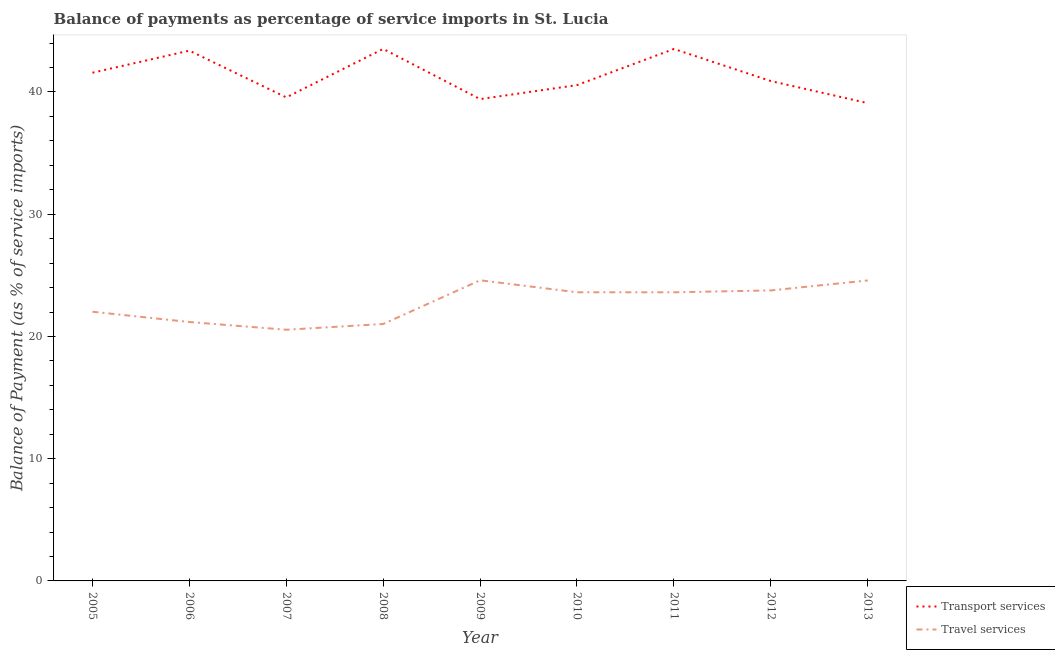Does the line corresponding to balance of payments of travel services intersect with the line corresponding to balance of payments of transport services?
Ensure brevity in your answer.  No. What is the balance of payments of travel services in 2009?
Make the answer very short. 24.6. Across all years, what is the maximum balance of payments of travel services?
Your response must be concise. 24.6. Across all years, what is the minimum balance of payments of travel services?
Your answer should be very brief. 20.55. In which year was the balance of payments of transport services minimum?
Make the answer very short. 2013. What is the total balance of payments of transport services in the graph?
Your answer should be compact. 371.53. What is the difference between the balance of payments of travel services in 2006 and that in 2011?
Your answer should be very brief. -2.43. What is the difference between the balance of payments of transport services in 2007 and the balance of payments of travel services in 2011?
Keep it short and to the point. 15.95. What is the average balance of payments of transport services per year?
Your answer should be very brief. 41.28. In the year 2009, what is the difference between the balance of payments of travel services and balance of payments of transport services?
Your response must be concise. -14.82. What is the ratio of the balance of payments of travel services in 2006 to that in 2009?
Offer a very short reply. 0.86. Is the difference between the balance of payments of travel services in 2007 and 2011 greater than the difference between the balance of payments of transport services in 2007 and 2011?
Keep it short and to the point. Yes. What is the difference between the highest and the second highest balance of payments of travel services?
Your answer should be very brief. 0.01. What is the difference between the highest and the lowest balance of payments of transport services?
Your response must be concise. 4.43. In how many years, is the balance of payments of travel services greater than the average balance of payments of travel services taken over all years?
Your answer should be very brief. 5. Is the balance of payments of travel services strictly less than the balance of payments of transport services over the years?
Make the answer very short. Yes. How many years are there in the graph?
Your answer should be compact. 9. What is the difference between two consecutive major ticks on the Y-axis?
Offer a terse response. 10. Does the graph contain grids?
Provide a succinct answer. No. Where does the legend appear in the graph?
Your answer should be compact. Bottom right. What is the title of the graph?
Your response must be concise. Balance of payments as percentage of service imports in St. Lucia. Does "Non-pregnant women" appear as one of the legend labels in the graph?
Make the answer very short. No. What is the label or title of the Y-axis?
Keep it short and to the point. Balance of Payment (as % of service imports). What is the Balance of Payment (as % of service imports) in Transport services in 2005?
Give a very brief answer. 41.58. What is the Balance of Payment (as % of service imports) in Travel services in 2005?
Provide a short and direct response. 22.02. What is the Balance of Payment (as % of service imports) of Transport services in 2006?
Ensure brevity in your answer.  43.38. What is the Balance of Payment (as % of service imports) in Travel services in 2006?
Ensure brevity in your answer.  21.18. What is the Balance of Payment (as % of service imports) of Transport services in 2007?
Ensure brevity in your answer.  39.56. What is the Balance of Payment (as % of service imports) in Travel services in 2007?
Your response must be concise. 20.55. What is the Balance of Payment (as % of service imports) in Transport services in 2008?
Make the answer very short. 43.52. What is the Balance of Payment (as % of service imports) in Travel services in 2008?
Keep it short and to the point. 21.02. What is the Balance of Payment (as % of service imports) of Transport services in 2009?
Give a very brief answer. 39.42. What is the Balance of Payment (as % of service imports) in Travel services in 2009?
Give a very brief answer. 24.6. What is the Balance of Payment (as % of service imports) of Transport services in 2010?
Keep it short and to the point. 40.56. What is the Balance of Payment (as % of service imports) of Travel services in 2010?
Ensure brevity in your answer.  23.61. What is the Balance of Payment (as % of service imports) of Transport services in 2011?
Ensure brevity in your answer.  43.52. What is the Balance of Payment (as % of service imports) in Travel services in 2011?
Make the answer very short. 23.61. What is the Balance of Payment (as % of service imports) in Transport services in 2012?
Make the answer very short. 40.9. What is the Balance of Payment (as % of service imports) in Travel services in 2012?
Make the answer very short. 23.77. What is the Balance of Payment (as % of service imports) in Transport services in 2013?
Your response must be concise. 39.09. What is the Balance of Payment (as % of service imports) of Travel services in 2013?
Keep it short and to the point. 24.58. Across all years, what is the maximum Balance of Payment (as % of service imports) of Transport services?
Your answer should be compact. 43.52. Across all years, what is the maximum Balance of Payment (as % of service imports) of Travel services?
Give a very brief answer. 24.6. Across all years, what is the minimum Balance of Payment (as % of service imports) in Transport services?
Your answer should be very brief. 39.09. Across all years, what is the minimum Balance of Payment (as % of service imports) in Travel services?
Ensure brevity in your answer.  20.55. What is the total Balance of Payment (as % of service imports) of Transport services in the graph?
Make the answer very short. 371.53. What is the total Balance of Payment (as % of service imports) of Travel services in the graph?
Provide a succinct answer. 204.95. What is the difference between the Balance of Payment (as % of service imports) of Transport services in 2005 and that in 2006?
Offer a very short reply. -1.81. What is the difference between the Balance of Payment (as % of service imports) in Travel services in 2005 and that in 2006?
Provide a succinct answer. 0.84. What is the difference between the Balance of Payment (as % of service imports) of Transport services in 2005 and that in 2007?
Your answer should be very brief. 2.02. What is the difference between the Balance of Payment (as % of service imports) in Travel services in 2005 and that in 2007?
Your answer should be compact. 1.47. What is the difference between the Balance of Payment (as % of service imports) in Transport services in 2005 and that in 2008?
Your response must be concise. -1.95. What is the difference between the Balance of Payment (as % of service imports) of Travel services in 2005 and that in 2008?
Provide a succinct answer. 1. What is the difference between the Balance of Payment (as % of service imports) of Transport services in 2005 and that in 2009?
Keep it short and to the point. 2.16. What is the difference between the Balance of Payment (as % of service imports) of Travel services in 2005 and that in 2009?
Make the answer very short. -2.57. What is the difference between the Balance of Payment (as % of service imports) in Transport services in 2005 and that in 2010?
Give a very brief answer. 1.01. What is the difference between the Balance of Payment (as % of service imports) of Travel services in 2005 and that in 2010?
Offer a terse response. -1.59. What is the difference between the Balance of Payment (as % of service imports) in Transport services in 2005 and that in 2011?
Ensure brevity in your answer.  -1.94. What is the difference between the Balance of Payment (as % of service imports) in Travel services in 2005 and that in 2011?
Your response must be concise. -1.59. What is the difference between the Balance of Payment (as % of service imports) in Transport services in 2005 and that in 2012?
Ensure brevity in your answer.  0.68. What is the difference between the Balance of Payment (as % of service imports) of Travel services in 2005 and that in 2012?
Your response must be concise. -1.74. What is the difference between the Balance of Payment (as % of service imports) of Transport services in 2005 and that in 2013?
Offer a terse response. 2.49. What is the difference between the Balance of Payment (as % of service imports) of Travel services in 2005 and that in 2013?
Provide a short and direct response. -2.56. What is the difference between the Balance of Payment (as % of service imports) of Transport services in 2006 and that in 2007?
Offer a terse response. 3.83. What is the difference between the Balance of Payment (as % of service imports) of Travel services in 2006 and that in 2007?
Provide a short and direct response. 0.63. What is the difference between the Balance of Payment (as % of service imports) in Transport services in 2006 and that in 2008?
Give a very brief answer. -0.14. What is the difference between the Balance of Payment (as % of service imports) in Travel services in 2006 and that in 2008?
Provide a succinct answer. 0.16. What is the difference between the Balance of Payment (as % of service imports) in Transport services in 2006 and that in 2009?
Keep it short and to the point. 3.97. What is the difference between the Balance of Payment (as % of service imports) of Travel services in 2006 and that in 2009?
Provide a short and direct response. -3.41. What is the difference between the Balance of Payment (as % of service imports) in Transport services in 2006 and that in 2010?
Your answer should be compact. 2.82. What is the difference between the Balance of Payment (as % of service imports) of Travel services in 2006 and that in 2010?
Offer a very short reply. -2.43. What is the difference between the Balance of Payment (as % of service imports) in Transport services in 2006 and that in 2011?
Offer a terse response. -0.14. What is the difference between the Balance of Payment (as % of service imports) of Travel services in 2006 and that in 2011?
Your answer should be compact. -2.43. What is the difference between the Balance of Payment (as % of service imports) of Transport services in 2006 and that in 2012?
Provide a short and direct response. 2.49. What is the difference between the Balance of Payment (as % of service imports) in Travel services in 2006 and that in 2012?
Keep it short and to the point. -2.58. What is the difference between the Balance of Payment (as % of service imports) of Transport services in 2006 and that in 2013?
Your answer should be very brief. 4.29. What is the difference between the Balance of Payment (as % of service imports) of Travel services in 2006 and that in 2013?
Offer a very short reply. -3.4. What is the difference between the Balance of Payment (as % of service imports) of Transport services in 2007 and that in 2008?
Ensure brevity in your answer.  -3.97. What is the difference between the Balance of Payment (as % of service imports) in Travel services in 2007 and that in 2008?
Give a very brief answer. -0.47. What is the difference between the Balance of Payment (as % of service imports) in Transport services in 2007 and that in 2009?
Keep it short and to the point. 0.14. What is the difference between the Balance of Payment (as % of service imports) in Travel services in 2007 and that in 2009?
Provide a succinct answer. -4.05. What is the difference between the Balance of Payment (as % of service imports) of Transport services in 2007 and that in 2010?
Keep it short and to the point. -1.01. What is the difference between the Balance of Payment (as % of service imports) of Travel services in 2007 and that in 2010?
Keep it short and to the point. -3.06. What is the difference between the Balance of Payment (as % of service imports) of Transport services in 2007 and that in 2011?
Offer a very short reply. -3.96. What is the difference between the Balance of Payment (as % of service imports) of Travel services in 2007 and that in 2011?
Your answer should be very brief. -3.06. What is the difference between the Balance of Payment (as % of service imports) of Transport services in 2007 and that in 2012?
Ensure brevity in your answer.  -1.34. What is the difference between the Balance of Payment (as % of service imports) of Travel services in 2007 and that in 2012?
Ensure brevity in your answer.  -3.22. What is the difference between the Balance of Payment (as % of service imports) of Transport services in 2007 and that in 2013?
Ensure brevity in your answer.  0.47. What is the difference between the Balance of Payment (as % of service imports) in Travel services in 2007 and that in 2013?
Provide a succinct answer. -4.03. What is the difference between the Balance of Payment (as % of service imports) of Transport services in 2008 and that in 2009?
Offer a very short reply. 4.11. What is the difference between the Balance of Payment (as % of service imports) in Travel services in 2008 and that in 2009?
Offer a terse response. -3.58. What is the difference between the Balance of Payment (as % of service imports) of Transport services in 2008 and that in 2010?
Keep it short and to the point. 2.96. What is the difference between the Balance of Payment (as % of service imports) of Travel services in 2008 and that in 2010?
Your response must be concise. -2.59. What is the difference between the Balance of Payment (as % of service imports) of Transport services in 2008 and that in 2011?
Your response must be concise. 0. What is the difference between the Balance of Payment (as % of service imports) of Travel services in 2008 and that in 2011?
Make the answer very short. -2.59. What is the difference between the Balance of Payment (as % of service imports) of Transport services in 2008 and that in 2012?
Your answer should be compact. 2.63. What is the difference between the Balance of Payment (as % of service imports) of Travel services in 2008 and that in 2012?
Your answer should be compact. -2.75. What is the difference between the Balance of Payment (as % of service imports) in Transport services in 2008 and that in 2013?
Make the answer very short. 4.43. What is the difference between the Balance of Payment (as % of service imports) in Travel services in 2008 and that in 2013?
Your response must be concise. -3.56. What is the difference between the Balance of Payment (as % of service imports) of Transport services in 2009 and that in 2010?
Your response must be concise. -1.15. What is the difference between the Balance of Payment (as % of service imports) of Travel services in 2009 and that in 2010?
Your answer should be very brief. 0.98. What is the difference between the Balance of Payment (as % of service imports) of Transport services in 2009 and that in 2011?
Your answer should be compact. -4.1. What is the difference between the Balance of Payment (as % of service imports) in Travel services in 2009 and that in 2011?
Your answer should be very brief. 0.98. What is the difference between the Balance of Payment (as % of service imports) in Transport services in 2009 and that in 2012?
Your response must be concise. -1.48. What is the difference between the Balance of Payment (as % of service imports) in Travel services in 2009 and that in 2012?
Your answer should be compact. 0.83. What is the difference between the Balance of Payment (as % of service imports) in Transport services in 2009 and that in 2013?
Offer a terse response. 0.33. What is the difference between the Balance of Payment (as % of service imports) of Travel services in 2009 and that in 2013?
Make the answer very short. 0.01. What is the difference between the Balance of Payment (as % of service imports) in Transport services in 2010 and that in 2011?
Your answer should be very brief. -2.96. What is the difference between the Balance of Payment (as % of service imports) of Travel services in 2010 and that in 2011?
Give a very brief answer. 0. What is the difference between the Balance of Payment (as % of service imports) of Transport services in 2010 and that in 2012?
Offer a terse response. -0.33. What is the difference between the Balance of Payment (as % of service imports) of Travel services in 2010 and that in 2012?
Give a very brief answer. -0.15. What is the difference between the Balance of Payment (as % of service imports) of Transport services in 2010 and that in 2013?
Your answer should be very brief. 1.47. What is the difference between the Balance of Payment (as % of service imports) of Travel services in 2010 and that in 2013?
Your answer should be compact. -0.97. What is the difference between the Balance of Payment (as % of service imports) of Transport services in 2011 and that in 2012?
Provide a succinct answer. 2.62. What is the difference between the Balance of Payment (as % of service imports) of Travel services in 2011 and that in 2012?
Provide a succinct answer. -0.15. What is the difference between the Balance of Payment (as % of service imports) of Transport services in 2011 and that in 2013?
Provide a short and direct response. 4.43. What is the difference between the Balance of Payment (as % of service imports) in Travel services in 2011 and that in 2013?
Give a very brief answer. -0.97. What is the difference between the Balance of Payment (as % of service imports) of Transport services in 2012 and that in 2013?
Make the answer very short. 1.81. What is the difference between the Balance of Payment (as % of service imports) in Travel services in 2012 and that in 2013?
Your answer should be very brief. -0.82. What is the difference between the Balance of Payment (as % of service imports) of Transport services in 2005 and the Balance of Payment (as % of service imports) of Travel services in 2006?
Make the answer very short. 20.4. What is the difference between the Balance of Payment (as % of service imports) in Transport services in 2005 and the Balance of Payment (as % of service imports) in Travel services in 2007?
Offer a terse response. 21.03. What is the difference between the Balance of Payment (as % of service imports) in Transport services in 2005 and the Balance of Payment (as % of service imports) in Travel services in 2008?
Your answer should be compact. 20.56. What is the difference between the Balance of Payment (as % of service imports) of Transport services in 2005 and the Balance of Payment (as % of service imports) of Travel services in 2009?
Your answer should be very brief. 16.98. What is the difference between the Balance of Payment (as % of service imports) of Transport services in 2005 and the Balance of Payment (as % of service imports) of Travel services in 2010?
Ensure brevity in your answer.  17.96. What is the difference between the Balance of Payment (as % of service imports) of Transport services in 2005 and the Balance of Payment (as % of service imports) of Travel services in 2011?
Provide a succinct answer. 17.96. What is the difference between the Balance of Payment (as % of service imports) of Transport services in 2005 and the Balance of Payment (as % of service imports) of Travel services in 2012?
Your answer should be compact. 17.81. What is the difference between the Balance of Payment (as % of service imports) of Transport services in 2005 and the Balance of Payment (as % of service imports) of Travel services in 2013?
Provide a succinct answer. 17. What is the difference between the Balance of Payment (as % of service imports) of Transport services in 2006 and the Balance of Payment (as % of service imports) of Travel services in 2007?
Provide a succinct answer. 22.83. What is the difference between the Balance of Payment (as % of service imports) in Transport services in 2006 and the Balance of Payment (as % of service imports) in Travel services in 2008?
Make the answer very short. 22.36. What is the difference between the Balance of Payment (as % of service imports) of Transport services in 2006 and the Balance of Payment (as % of service imports) of Travel services in 2009?
Ensure brevity in your answer.  18.79. What is the difference between the Balance of Payment (as % of service imports) in Transport services in 2006 and the Balance of Payment (as % of service imports) in Travel services in 2010?
Provide a succinct answer. 19.77. What is the difference between the Balance of Payment (as % of service imports) of Transport services in 2006 and the Balance of Payment (as % of service imports) of Travel services in 2011?
Your response must be concise. 19.77. What is the difference between the Balance of Payment (as % of service imports) in Transport services in 2006 and the Balance of Payment (as % of service imports) in Travel services in 2012?
Offer a terse response. 19.62. What is the difference between the Balance of Payment (as % of service imports) of Transport services in 2006 and the Balance of Payment (as % of service imports) of Travel services in 2013?
Provide a succinct answer. 18.8. What is the difference between the Balance of Payment (as % of service imports) in Transport services in 2007 and the Balance of Payment (as % of service imports) in Travel services in 2008?
Offer a terse response. 18.54. What is the difference between the Balance of Payment (as % of service imports) of Transport services in 2007 and the Balance of Payment (as % of service imports) of Travel services in 2009?
Your answer should be very brief. 14.96. What is the difference between the Balance of Payment (as % of service imports) in Transport services in 2007 and the Balance of Payment (as % of service imports) in Travel services in 2010?
Ensure brevity in your answer.  15.94. What is the difference between the Balance of Payment (as % of service imports) of Transport services in 2007 and the Balance of Payment (as % of service imports) of Travel services in 2011?
Offer a very short reply. 15.95. What is the difference between the Balance of Payment (as % of service imports) of Transport services in 2007 and the Balance of Payment (as % of service imports) of Travel services in 2012?
Your answer should be very brief. 15.79. What is the difference between the Balance of Payment (as % of service imports) in Transport services in 2007 and the Balance of Payment (as % of service imports) in Travel services in 2013?
Offer a very short reply. 14.98. What is the difference between the Balance of Payment (as % of service imports) in Transport services in 2008 and the Balance of Payment (as % of service imports) in Travel services in 2009?
Ensure brevity in your answer.  18.93. What is the difference between the Balance of Payment (as % of service imports) of Transport services in 2008 and the Balance of Payment (as % of service imports) of Travel services in 2010?
Make the answer very short. 19.91. What is the difference between the Balance of Payment (as % of service imports) in Transport services in 2008 and the Balance of Payment (as % of service imports) in Travel services in 2011?
Offer a terse response. 19.91. What is the difference between the Balance of Payment (as % of service imports) in Transport services in 2008 and the Balance of Payment (as % of service imports) in Travel services in 2012?
Keep it short and to the point. 19.76. What is the difference between the Balance of Payment (as % of service imports) in Transport services in 2008 and the Balance of Payment (as % of service imports) in Travel services in 2013?
Provide a succinct answer. 18.94. What is the difference between the Balance of Payment (as % of service imports) of Transport services in 2009 and the Balance of Payment (as % of service imports) of Travel services in 2010?
Your answer should be very brief. 15.8. What is the difference between the Balance of Payment (as % of service imports) in Transport services in 2009 and the Balance of Payment (as % of service imports) in Travel services in 2011?
Your response must be concise. 15.81. What is the difference between the Balance of Payment (as % of service imports) of Transport services in 2009 and the Balance of Payment (as % of service imports) of Travel services in 2012?
Offer a terse response. 15.65. What is the difference between the Balance of Payment (as % of service imports) in Transport services in 2009 and the Balance of Payment (as % of service imports) in Travel services in 2013?
Your answer should be very brief. 14.84. What is the difference between the Balance of Payment (as % of service imports) in Transport services in 2010 and the Balance of Payment (as % of service imports) in Travel services in 2011?
Provide a short and direct response. 16.95. What is the difference between the Balance of Payment (as % of service imports) of Transport services in 2010 and the Balance of Payment (as % of service imports) of Travel services in 2012?
Make the answer very short. 16.8. What is the difference between the Balance of Payment (as % of service imports) in Transport services in 2010 and the Balance of Payment (as % of service imports) in Travel services in 2013?
Offer a terse response. 15.98. What is the difference between the Balance of Payment (as % of service imports) in Transport services in 2011 and the Balance of Payment (as % of service imports) in Travel services in 2012?
Keep it short and to the point. 19.75. What is the difference between the Balance of Payment (as % of service imports) of Transport services in 2011 and the Balance of Payment (as % of service imports) of Travel services in 2013?
Provide a short and direct response. 18.94. What is the difference between the Balance of Payment (as % of service imports) in Transport services in 2012 and the Balance of Payment (as % of service imports) in Travel services in 2013?
Keep it short and to the point. 16.31. What is the average Balance of Payment (as % of service imports) in Transport services per year?
Ensure brevity in your answer.  41.28. What is the average Balance of Payment (as % of service imports) of Travel services per year?
Your response must be concise. 22.77. In the year 2005, what is the difference between the Balance of Payment (as % of service imports) in Transport services and Balance of Payment (as % of service imports) in Travel services?
Offer a terse response. 19.55. In the year 2006, what is the difference between the Balance of Payment (as % of service imports) of Transport services and Balance of Payment (as % of service imports) of Travel services?
Make the answer very short. 22.2. In the year 2007, what is the difference between the Balance of Payment (as % of service imports) in Transport services and Balance of Payment (as % of service imports) in Travel services?
Your answer should be compact. 19.01. In the year 2008, what is the difference between the Balance of Payment (as % of service imports) in Transport services and Balance of Payment (as % of service imports) in Travel services?
Offer a very short reply. 22.5. In the year 2009, what is the difference between the Balance of Payment (as % of service imports) in Transport services and Balance of Payment (as % of service imports) in Travel services?
Give a very brief answer. 14.82. In the year 2010, what is the difference between the Balance of Payment (as % of service imports) in Transport services and Balance of Payment (as % of service imports) in Travel services?
Your answer should be compact. 16.95. In the year 2011, what is the difference between the Balance of Payment (as % of service imports) of Transport services and Balance of Payment (as % of service imports) of Travel services?
Provide a succinct answer. 19.91. In the year 2012, what is the difference between the Balance of Payment (as % of service imports) of Transport services and Balance of Payment (as % of service imports) of Travel services?
Keep it short and to the point. 17.13. In the year 2013, what is the difference between the Balance of Payment (as % of service imports) of Transport services and Balance of Payment (as % of service imports) of Travel services?
Keep it short and to the point. 14.51. What is the ratio of the Balance of Payment (as % of service imports) of Transport services in 2005 to that in 2006?
Your answer should be very brief. 0.96. What is the ratio of the Balance of Payment (as % of service imports) in Travel services in 2005 to that in 2006?
Give a very brief answer. 1.04. What is the ratio of the Balance of Payment (as % of service imports) in Transport services in 2005 to that in 2007?
Offer a very short reply. 1.05. What is the ratio of the Balance of Payment (as % of service imports) in Travel services in 2005 to that in 2007?
Keep it short and to the point. 1.07. What is the ratio of the Balance of Payment (as % of service imports) of Transport services in 2005 to that in 2008?
Your answer should be very brief. 0.96. What is the ratio of the Balance of Payment (as % of service imports) in Travel services in 2005 to that in 2008?
Provide a succinct answer. 1.05. What is the ratio of the Balance of Payment (as % of service imports) in Transport services in 2005 to that in 2009?
Your answer should be very brief. 1.05. What is the ratio of the Balance of Payment (as % of service imports) in Travel services in 2005 to that in 2009?
Provide a succinct answer. 0.9. What is the ratio of the Balance of Payment (as % of service imports) of Transport services in 2005 to that in 2010?
Make the answer very short. 1.02. What is the ratio of the Balance of Payment (as % of service imports) of Travel services in 2005 to that in 2010?
Provide a succinct answer. 0.93. What is the ratio of the Balance of Payment (as % of service imports) of Transport services in 2005 to that in 2011?
Offer a very short reply. 0.96. What is the ratio of the Balance of Payment (as % of service imports) of Travel services in 2005 to that in 2011?
Provide a succinct answer. 0.93. What is the ratio of the Balance of Payment (as % of service imports) in Transport services in 2005 to that in 2012?
Your answer should be compact. 1.02. What is the ratio of the Balance of Payment (as % of service imports) of Travel services in 2005 to that in 2012?
Give a very brief answer. 0.93. What is the ratio of the Balance of Payment (as % of service imports) of Transport services in 2005 to that in 2013?
Offer a very short reply. 1.06. What is the ratio of the Balance of Payment (as % of service imports) of Travel services in 2005 to that in 2013?
Keep it short and to the point. 0.9. What is the ratio of the Balance of Payment (as % of service imports) of Transport services in 2006 to that in 2007?
Offer a terse response. 1.1. What is the ratio of the Balance of Payment (as % of service imports) of Travel services in 2006 to that in 2007?
Your answer should be compact. 1.03. What is the ratio of the Balance of Payment (as % of service imports) in Transport services in 2006 to that in 2008?
Offer a very short reply. 1. What is the ratio of the Balance of Payment (as % of service imports) of Travel services in 2006 to that in 2008?
Offer a very short reply. 1.01. What is the ratio of the Balance of Payment (as % of service imports) of Transport services in 2006 to that in 2009?
Provide a succinct answer. 1.1. What is the ratio of the Balance of Payment (as % of service imports) in Travel services in 2006 to that in 2009?
Your response must be concise. 0.86. What is the ratio of the Balance of Payment (as % of service imports) in Transport services in 2006 to that in 2010?
Provide a short and direct response. 1.07. What is the ratio of the Balance of Payment (as % of service imports) of Travel services in 2006 to that in 2010?
Make the answer very short. 0.9. What is the ratio of the Balance of Payment (as % of service imports) in Transport services in 2006 to that in 2011?
Keep it short and to the point. 1. What is the ratio of the Balance of Payment (as % of service imports) of Travel services in 2006 to that in 2011?
Offer a terse response. 0.9. What is the ratio of the Balance of Payment (as % of service imports) of Transport services in 2006 to that in 2012?
Make the answer very short. 1.06. What is the ratio of the Balance of Payment (as % of service imports) of Travel services in 2006 to that in 2012?
Offer a very short reply. 0.89. What is the ratio of the Balance of Payment (as % of service imports) in Transport services in 2006 to that in 2013?
Make the answer very short. 1.11. What is the ratio of the Balance of Payment (as % of service imports) in Travel services in 2006 to that in 2013?
Your response must be concise. 0.86. What is the ratio of the Balance of Payment (as % of service imports) of Transport services in 2007 to that in 2008?
Provide a short and direct response. 0.91. What is the ratio of the Balance of Payment (as % of service imports) in Travel services in 2007 to that in 2008?
Keep it short and to the point. 0.98. What is the ratio of the Balance of Payment (as % of service imports) in Travel services in 2007 to that in 2009?
Keep it short and to the point. 0.84. What is the ratio of the Balance of Payment (as % of service imports) of Transport services in 2007 to that in 2010?
Offer a terse response. 0.98. What is the ratio of the Balance of Payment (as % of service imports) in Travel services in 2007 to that in 2010?
Your answer should be very brief. 0.87. What is the ratio of the Balance of Payment (as % of service imports) in Transport services in 2007 to that in 2011?
Offer a very short reply. 0.91. What is the ratio of the Balance of Payment (as % of service imports) of Travel services in 2007 to that in 2011?
Offer a terse response. 0.87. What is the ratio of the Balance of Payment (as % of service imports) in Transport services in 2007 to that in 2012?
Give a very brief answer. 0.97. What is the ratio of the Balance of Payment (as % of service imports) of Travel services in 2007 to that in 2012?
Your answer should be very brief. 0.86. What is the ratio of the Balance of Payment (as % of service imports) in Transport services in 2007 to that in 2013?
Offer a very short reply. 1.01. What is the ratio of the Balance of Payment (as % of service imports) in Travel services in 2007 to that in 2013?
Ensure brevity in your answer.  0.84. What is the ratio of the Balance of Payment (as % of service imports) in Transport services in 2008 to that in 2009?
Your answer should be very brief. 1.1. What is the ratio of the Balance of Payment (as % of service imports) in Travel services in 2008 to that in 2009?
Your answer should be compact. 0.85. What is the ratio of the Balance of Payment (as % of service imports) of Transport services in 2008 to that in 2010?
Provide a short and direct response. 1.07. What is the ratio of the Balance of Payment (as % of service imports) in Travel services in 2008 to that in 2010?
Your answer should be very brief. 0.89. What is the ratio of the Balance of Payment (as % of service imports) in Travel services in 2008 to that in 2011?
Provide a short and direct response. 0.89. What is the ratio of the Balance of Payment (as % of service imports) of Transport services in 2008 to that in 2012?
Give a very brief answer. 1.06. What is the ratio of the Balance of Payment (as % of service imports) in Travel services in 2008 to that in 2012?
Your response must be concise. 0.88. What is the ratio of the Balance of Payment (as % of service imports) in Transport services in 2008 to that in 2013?
Your answer should be compact. 1.11. What is the ratio of the Balance of Payment (as % of service imports) in Travel services in 2008 to that in 2013?
Offer a very short reply. 0.86. What is the ratio of the Balance of Payment (as % of service imports) of Transport services in 2009 to that in 2010?
Provide a succinct answer. 0.97. What is the ratio of the Balance of Payment (as % of service imports) in Travel services in 2009 to that in 2010?
Provide a succinct answer. 1.04. What is the ratio of the Balance of Payment (as % of service imports) of Transport services in 2009 to that in 2011?
Your answer should be compact. 0.91. What is the ratio of the Balance of Payment (as % of service imports) of Travel services in 2009 to that in 2011?
Your answer should be very brief. 1.04. What is the ratio of the Balance of Payment (as % of service imports) in Transport services in 2009 to that in 2012?
Your answer should be very brief. 0.96. What is the ratio of the Balance of Payment (as % of service imports) of Travel services in 2009 to that in 2012?
Your response must be concise. 1.03. What is the ratio of the Balance of Payment (as % of service imports) of Transport services in 2009 to that in 2013?
Your answer should be very brief. 1.01. What is the ratio of the Balance of Payment (as % of service imports) of Travel services in 2009 to that in 2013?
Provide a succinct answer. 1. What is the ratio of the Balance of Payment (as % of service imports) of Transport services in 2010 to that in 2011?
Ensure brevity in your answer.  0.93. What is the ratio of the Balance of Payment (as % of service imports) of Travel services in 2010 to that in 2011?
Provide a short and direct response. 1. What is the ratio of the Balance of Payment (as % of service imports) in Travel services in 2010 to that in 2012?
Offer a very short reply. 0.99. What is the ratio of the Balance of Payment (as % of service imports) of Transport services in 2010 to that in 2013?
Keep it short and to the point. 1.04. What is the ratio of the Balance of Payment (as % of service imports) in Travel services in 2010 to that in 2013?
Give a very brief answer. 0.96. What is the ratio of the Balance of Payment (as % of service imports) of Transport services in 2011 to that in 2012?
Give a very brief answer. 1.06. What is the ratio of the Balance of Payment (as % of service imports) of Travel services in 2011 to that in 2012?
Make the answer very short. 0.99. What is the ratio of the Balance of Payment (as % of service imports) in Transport services in 2011 to that in 2013?
Provide a succinct answer. 1.11. What is the ratio of the Balance of Payment (as % of service imports) of Travel services in 2011 to that in 2013?
Your answer should be very brief. 0.96. What is the ratio of the Balance of Payment (as % of service imports) in Transport services in 2012 to that in 2013?
Your answer should be very brief. 1.05. What is the ratio of the Balance of Payment (as % of service imports) of Travel services in 2012 to that in 2013?
Provide a succinct answer. 0.97. What is the difference between the highest and the second highest Balance of Payment (as % of service imports) in Transport services?
Your answer should be compact. 0. What is the difference between the highest and the second highest Balance of Payment (as % of service imports) in Travel services?
Your answer should be compact. 0.01. What is the difference between the highest and the lowest Balance of Payment (as % of service imports) in Transport services?
Your answer should be compact. 4.43. What is the difference between the highest and the lowest Balance of Payment (as % of service imports) of Travel services?
Provide a succinct answer. 4.05. 